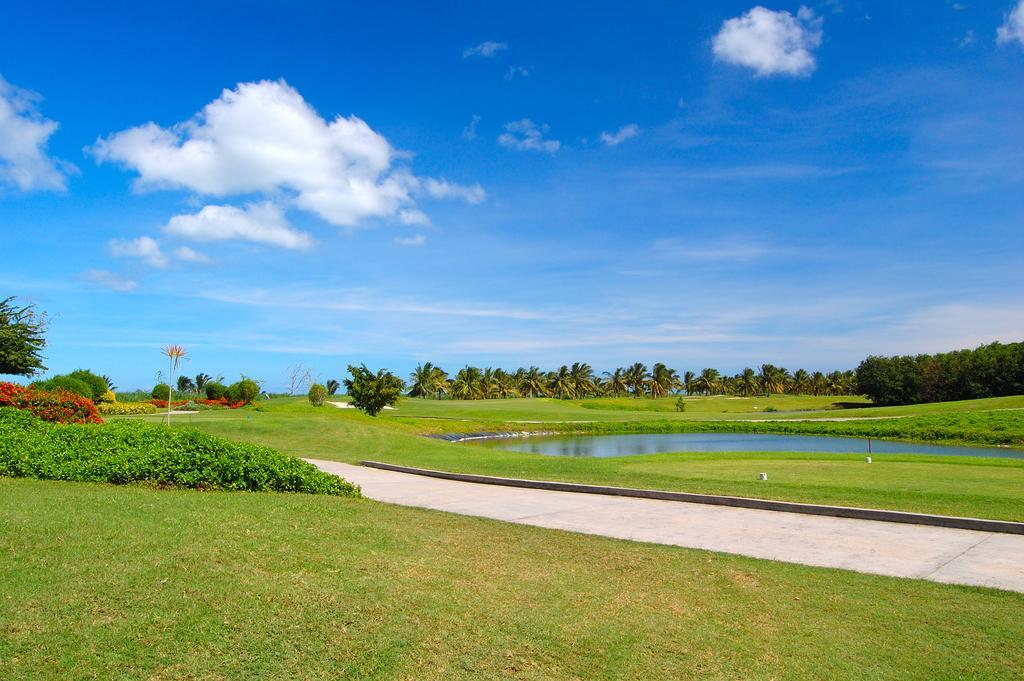Can you describe this image briefly? In this image we can see grass, trees and a pond of water. 